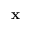Convert formula to latex. <formula><loc_0><loc_0><loc_500><loc_500>{ x }</formula> 